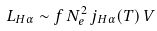Convert formula to latex. <formula><loc_0><loc_0><loc_500><loc_500>L _ { H \alpha } \sim f \, N _ { e } ^ { 2 } \, j _ { H \alpha } ( T ) \, V</formula> 